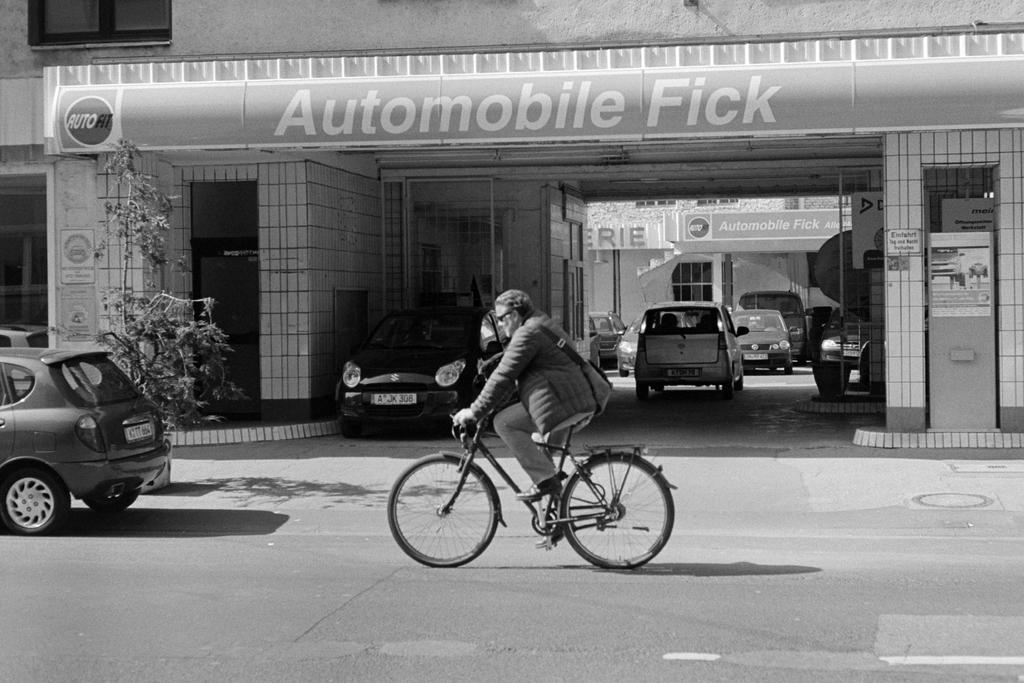What is the man doing in the image? The man is riding a bicycle in the image. Where is the man riding the bicycle? The man is on the road in the image. What else can be seen on the road in the image? There are cars in the image. What other elements are present in the image besides the man and the cars? There are plants and buildings in the image. What type of sign can be seen on the man's lips in the image? There is no sign visible on the man's lips in the image. How many trees are present in the image? The provided facts do not specify the number of trees in the image, only that there are plants present. 